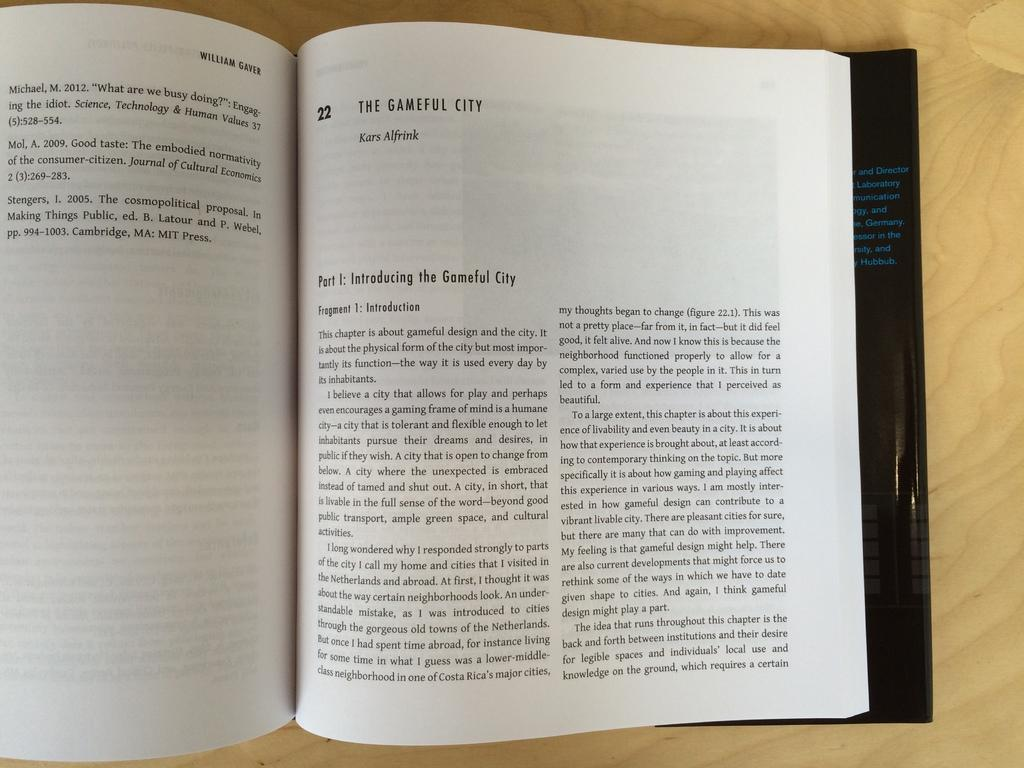Provide a one-sentence caption for the provided image. open book, the gameful city by william gaver. 